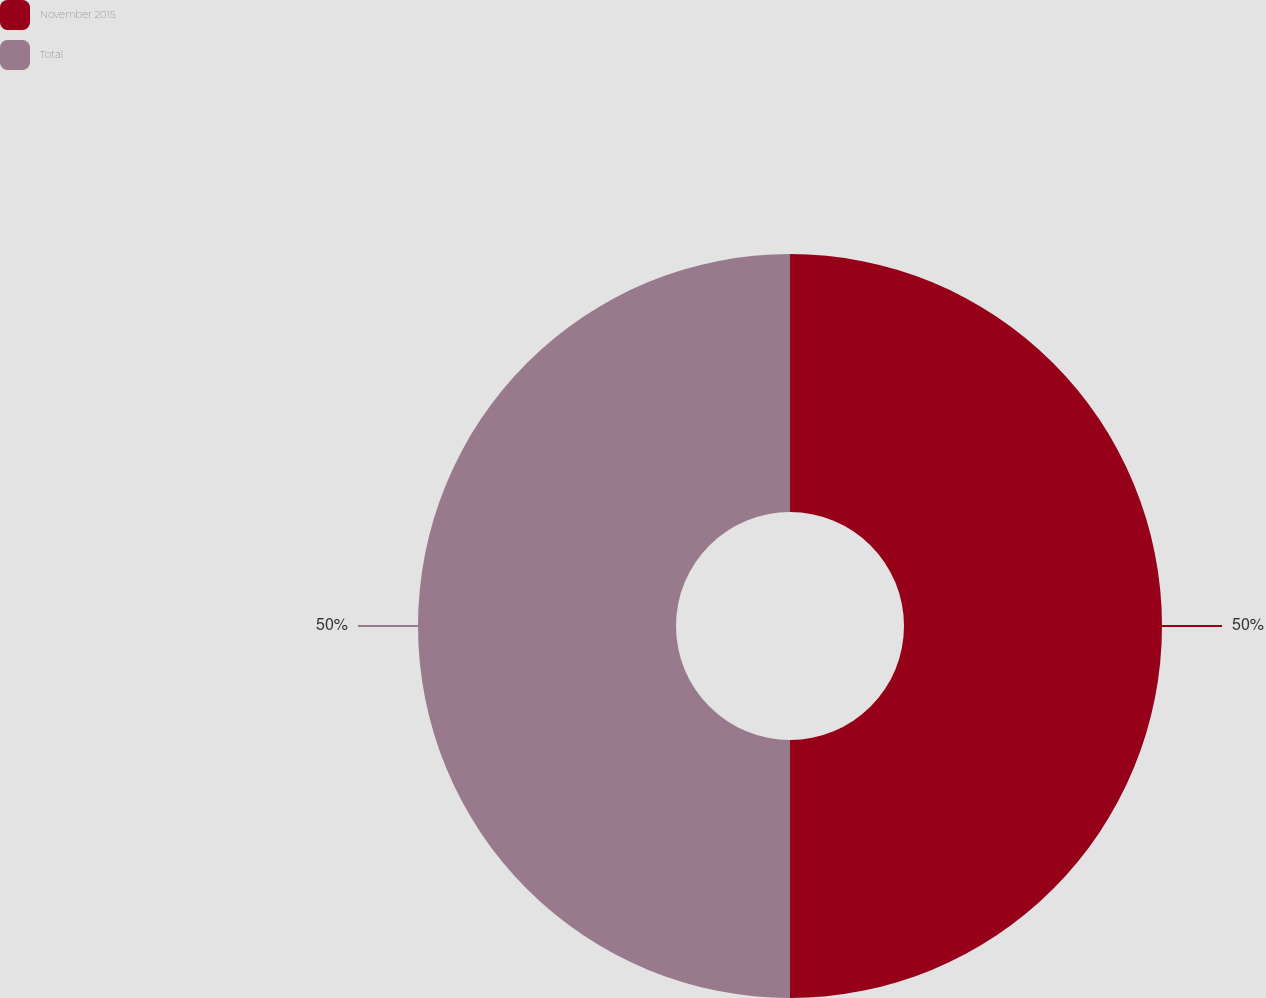Convert chart. <chart><loc_0><loc_0><loc_500><loc_500><pie_chart><fcel>November 2015<fcel>Total<nl><fcel>50.0%<fcel>50.0%<nl></chart> 